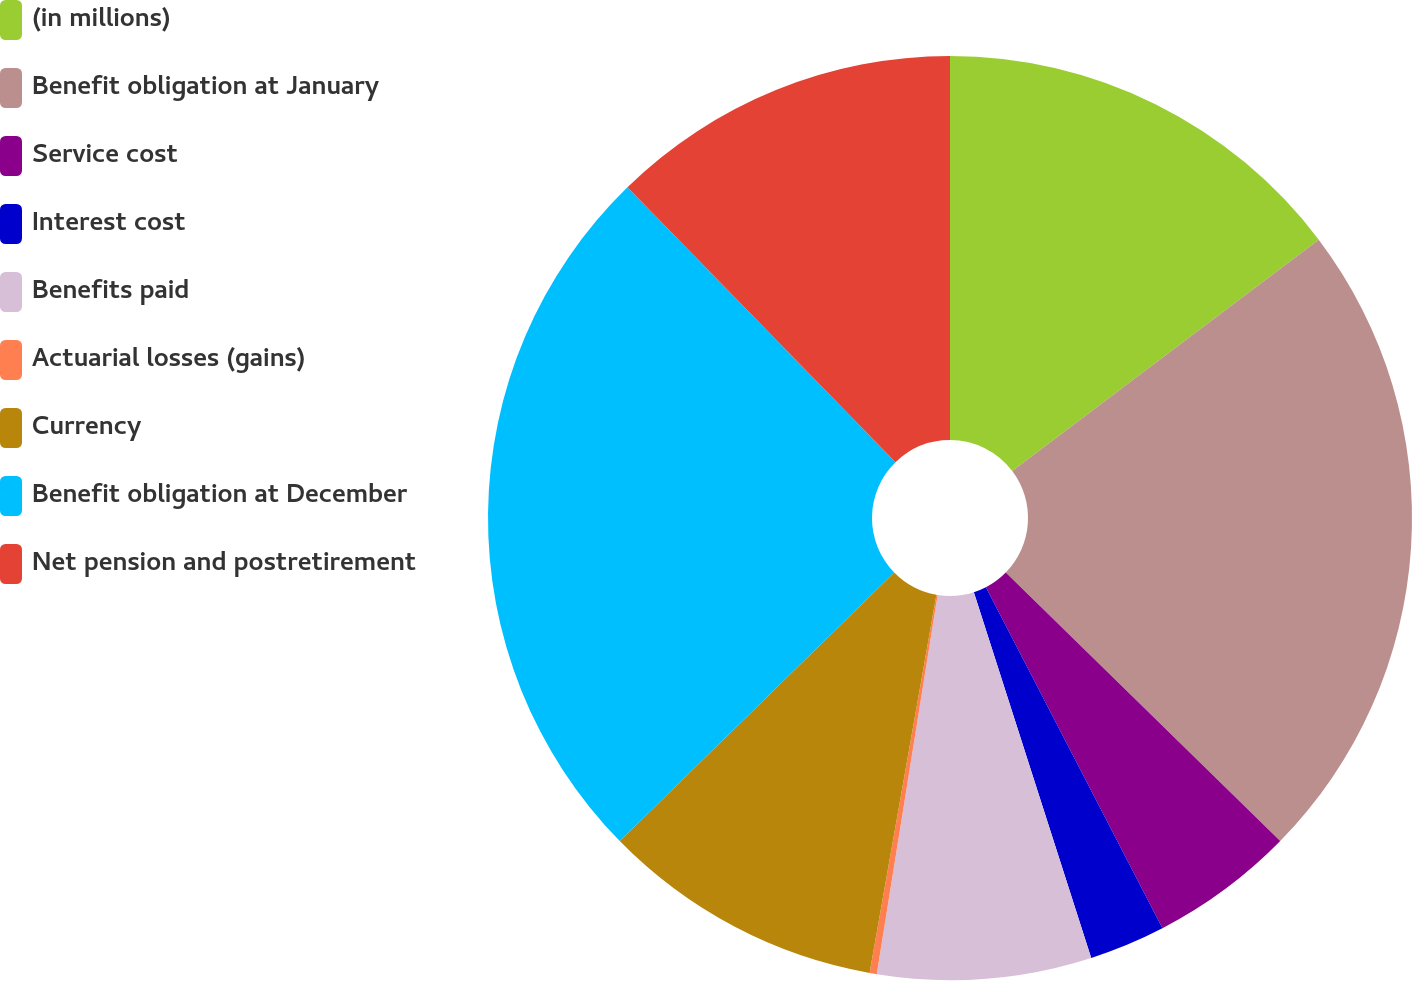<chart> <loc_0><loc_0><loc_500><loc_500><pie_chart><fcel>(in millions)<fcel>Benefit obligation at January<fcel>Service cost<fcel>Interest cost<fcel>Benefits paid<fcel>Actuarial losses (gains)<fcel>Currency<fcel>Benefit obligation at December<fcel>Net pension and postretirement<nl><fcel>14.71%<fcel>22.62%<fcel>5.07%<fcel>2.66%<fcel>7.48%<fcel>0.25%<fcel>9.89%<fcel>25.03%<fcel>12.3%<nl></chart> 